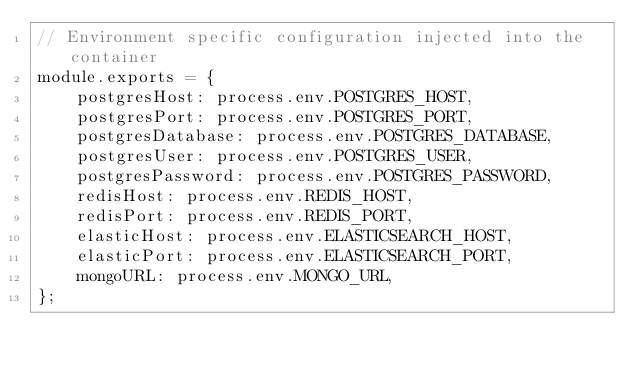<code> <loc_0><loc_0><loc_500><loc_500><_JavaScript_>// Environment specific configuration injected into the container
module.exports = {
    postgresHost: process.env.POSTGRES_HOST,
    postgresPort: process.env.POSTGRES_PORT,
    postgresDatabase: process.env.POSTGRES_DATABASE,
    postgresUser: process.env.POSTGRES_USER,
    postgresPassword: process.env.POSTGRES_PASSWORD,
    redisHost: process.env.REDIS_HOST,
    redisPort: process.env.REDIS_PORT,
    elasticHost: process.env.ELASTICSEARCH_HOST,
    elasticPort: process.env.ELASTICSEARCH_PORT,
    mongoURL: process.env.MONGO_URL,
};</code> 